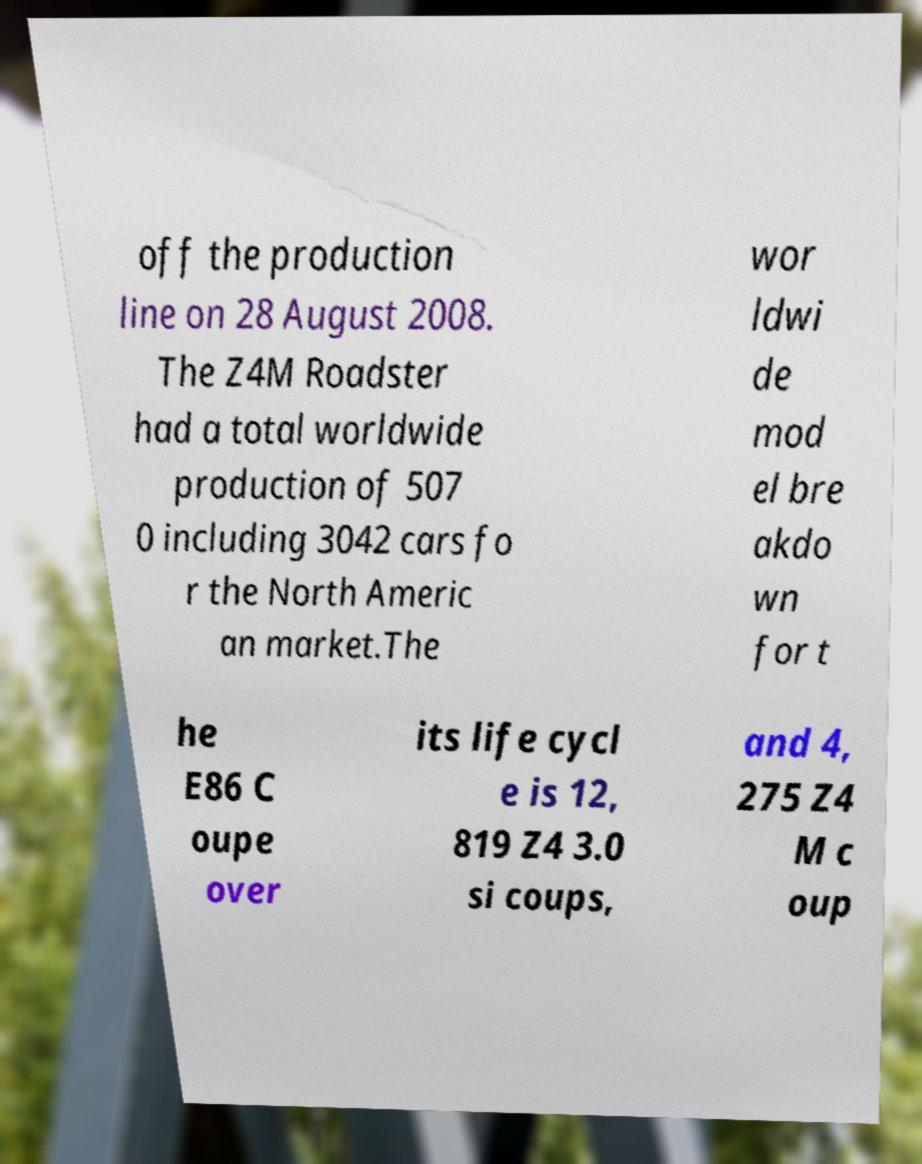Can you read and provide the text displayed in the image?This photo seems to have some interesting text. Can you extract and type it out for me? off the production line on 28 August 2008. The Z4M Roadster had a total worldwide production of 507 0 including 3042 cars fo r the North Americ an market.The wor ldwi de mod el bre akdo wn for t he E86 C oupe over its life cycl e is 12, 819 Z4 3.0 si coups, and 4, 275 Z4 M c oup 